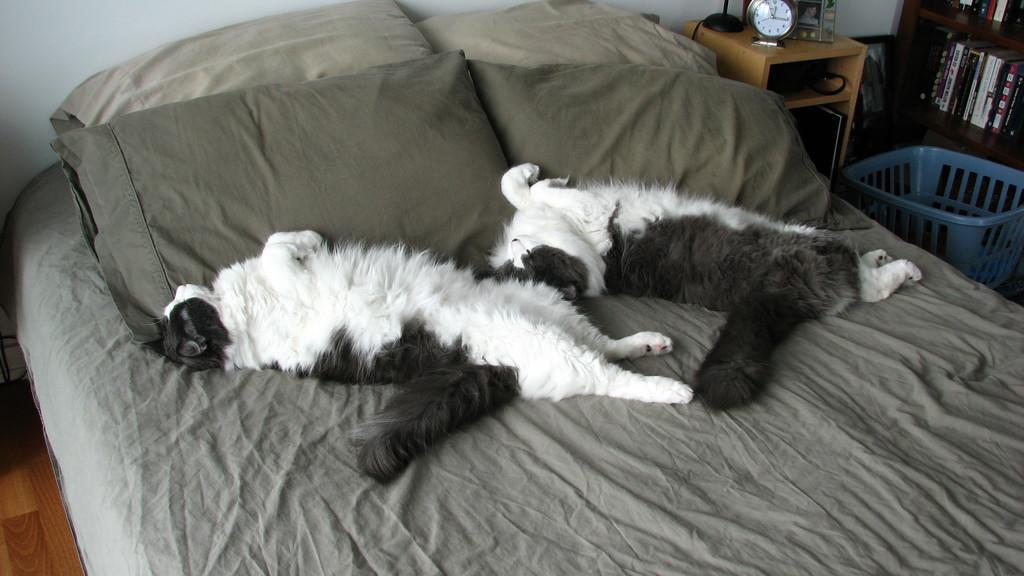Please provide a concise description of this image. In this image I can see two cats sleeping on the bed. The cat is in white and black color. I can see a grey color blanket and pillows. I can see a clock,frame and few objects on the table. I can see a book rack and blue color basket. 